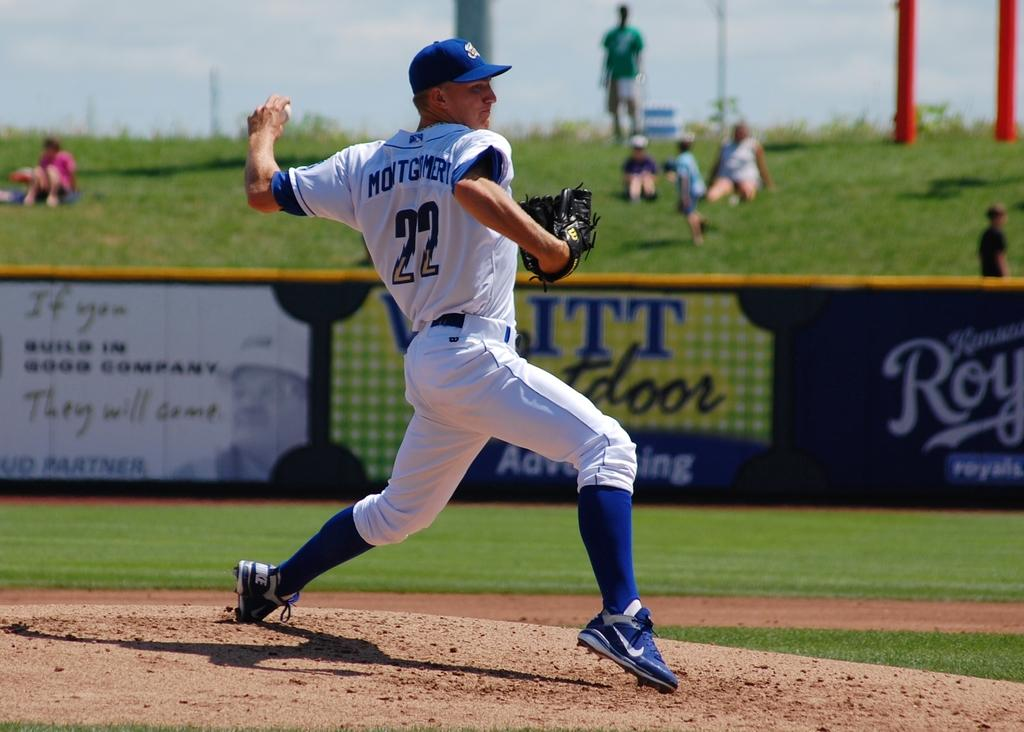<image>
Present a compact description of the photo's key features. Baseball player wearing jersey number 22 pitching the ball. 